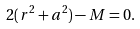<formula> <loc_0><loc_0><loc_500><loc_500>2 ( r ^ { 2 } + a ^ { 2 } ) - M = 0 .</formula> 